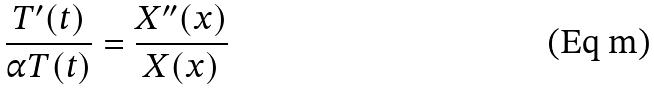<formula> <loc_0><loc_0><loc_500><loc_500>\frac { T ^ { \prime } ( t ) } { \alpha T ( t ) } = \frac { X ^ { \prime \prime } ( x ) } { X ( x ) }</formula> 